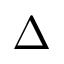<formula> <loc_0><loc_0><loc_500><loc_500>\Delta</formula> 